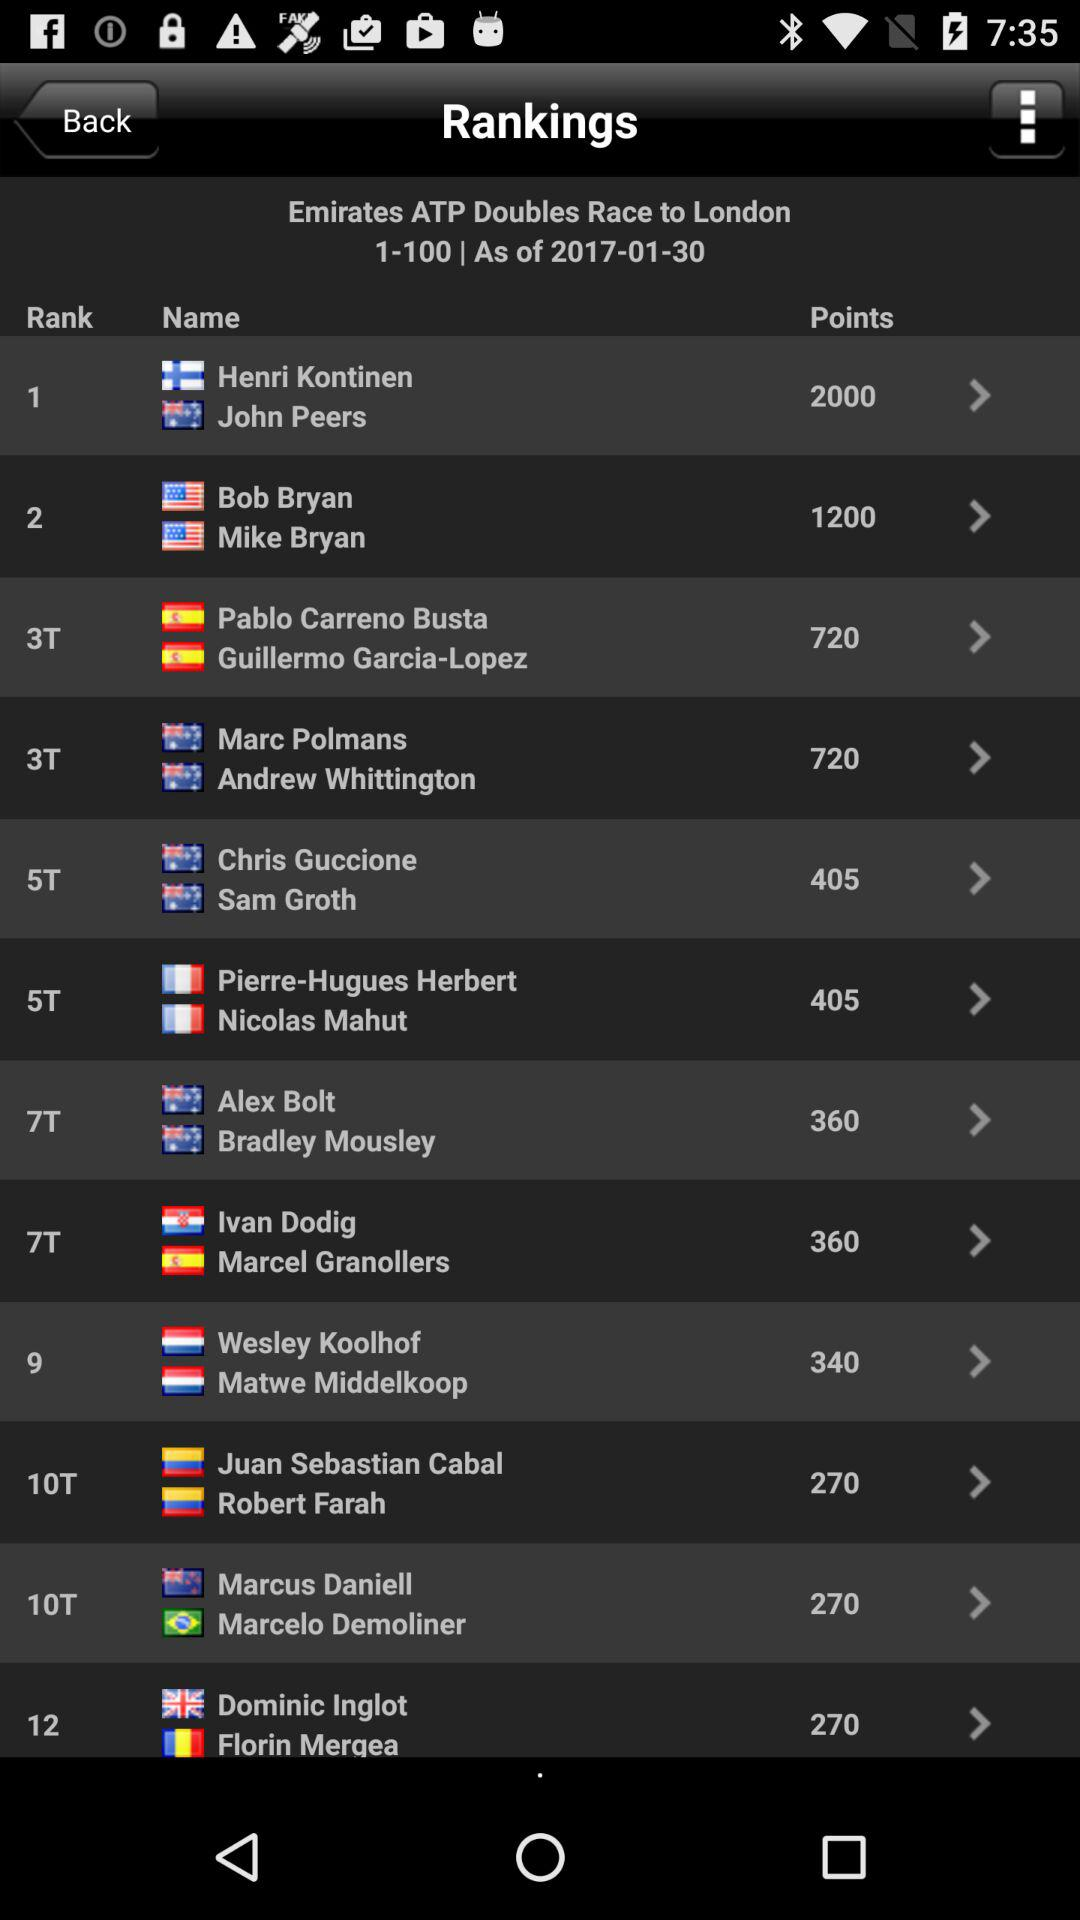How many more points does the top ranked player have than the second ranked player?
Answer the question using a single word or phrase. 800 